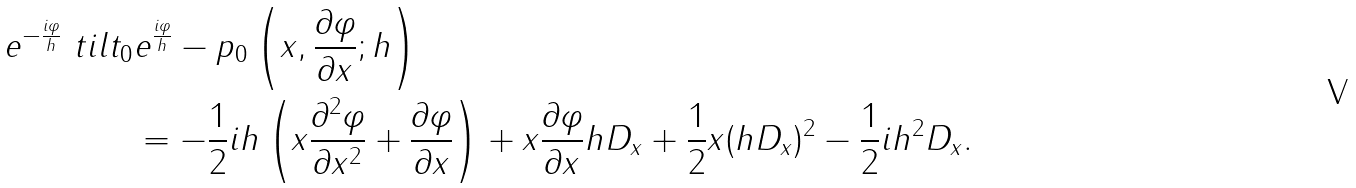<formula> <loc_0><loc_0><loc_500><loc_500>e ^ { - \frac { i \varphi } { h } } \ t i l t _ { 0 } & e ^ { \frac { i \varphi } { h } } - p _ { 0 } \left ( x , \frac { \partial \varphi } { \partial x } ; h \right ) \\ & = - \frac { 1 } { 2 } i h \left ( x \frac { \partial ^ { 2 } \varphi } { \partial x ^ { 2 } } + \frac { \partial \varphi } { \partial x } \right ) + x \frac { \partial \varphi } { \partial x } h D _ { x } + \frac { 1 } { 2 } x ( h D _ { x } ) ^ { 2 } - \frac { 1 } { 2 } i h ^ { 2 } D _ { x } .</formula> 